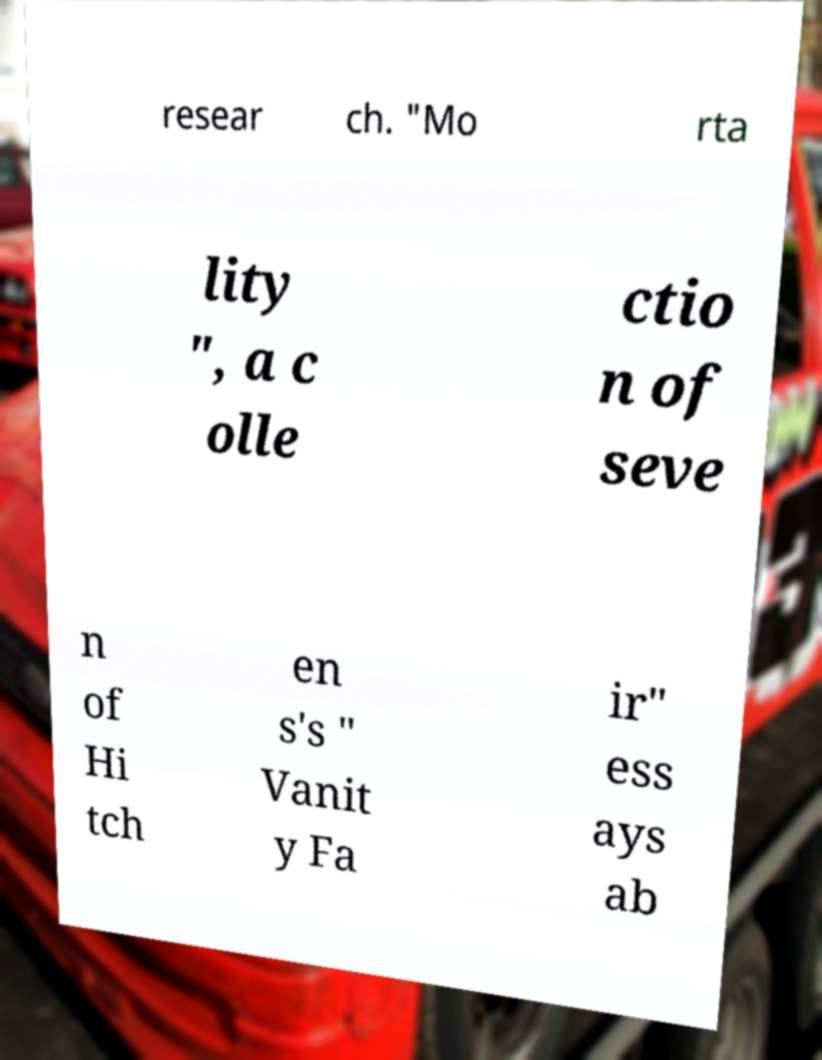I need the written content from this picture converted into text. Can you do that? resear ch. "Mo rta lity ", a c olle ctio n of seve n of Hi tch en s's " Vanit y Fa ir" ess ays ab 